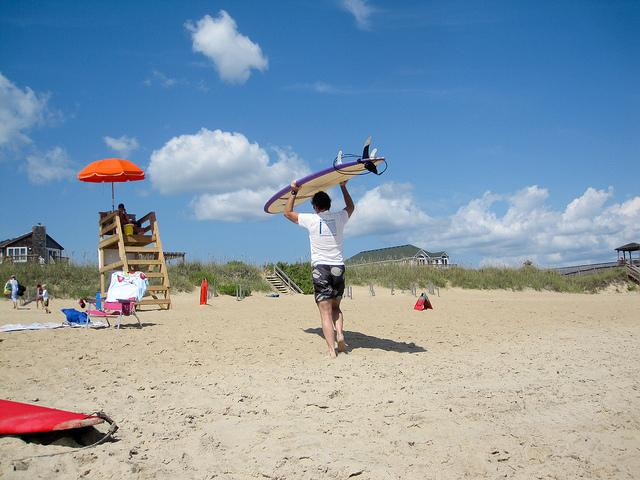What kind of view might be seen from the windows on the house?

Choices:
A) dirt view
B) sky view
C) office view
D) sea view sea view 